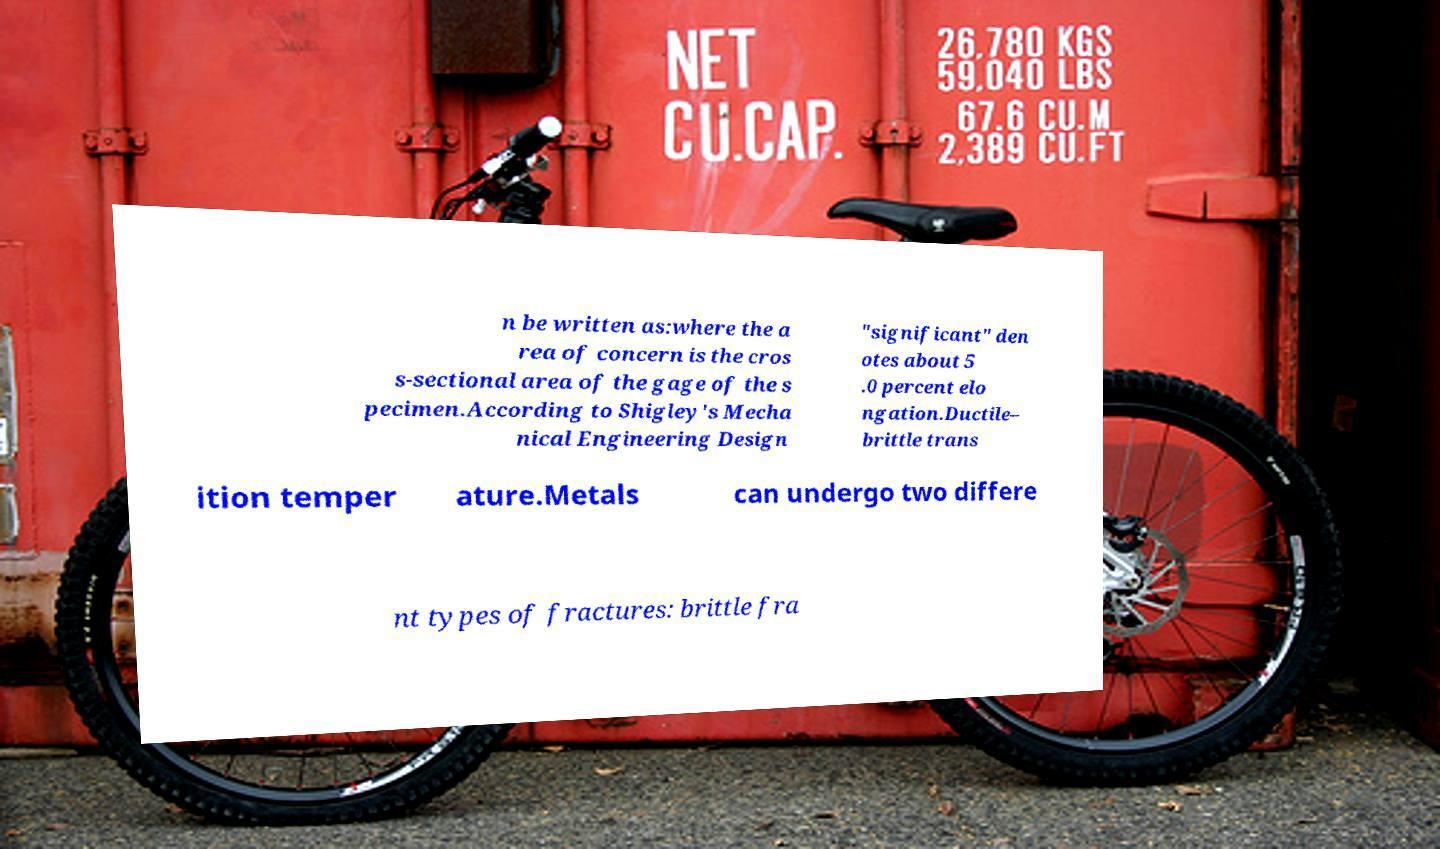For documentation purposes, I need the text within this image transcribed. Could you provide that? n be written as:where the a rea of concern is the cros s-sectional area of the gage of the s pecimen.According to Shigley's Mecha nical Engineering Design "significant" den otes about 5 .0 percent elo ngation.Ductile– brittle trans ition temper ature.Metals can undergo two differe nt types of fractures: brittle fra 